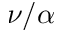Convert formula to latex. <formula><loc_0><loc_0><loc_500><loc_500>\nu / \alpha</formula> 